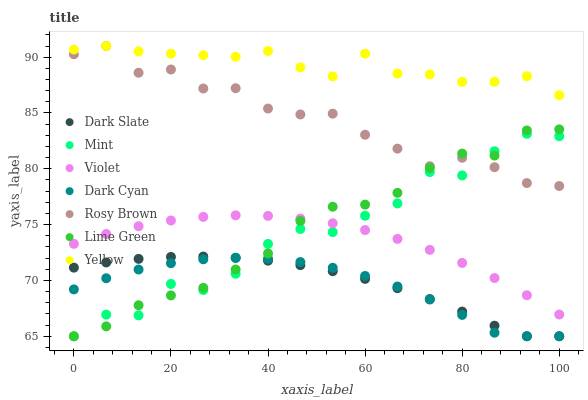Does Dark Cyan have the minimum area under the curve?
Answer yes or no. Yes. Does Yellow have the maximum area under the curve?
Answer yes or no. Yes. Does Rosy Brown have the minimum area under the curve?
Answer yes or no. No. Does Rosy Brown have the maximum area under the curve?
Answer yes or no. No. Is Violet the smoothest?
Answer yes or no. Yes. Is Mint the roughest?
Answer yes or no. Yes. Is Rosy Brown the smoothest?
Answer yes or no. No. Is Rosy Brown the roughest?
Answer yes or no. No. Does Lime Green have the lowest value?
Answer yes or no. Yes. Does Rosy Brown have the lowest value?
Answer yes or no. No. Does Yellow have the highest value?
Answer yes or no. Yes. Does Dark Slate have the highest value?
Answer yes or no. No. Is Dark Slate less than Violet?
Answer yes or no. Yes. Is Rosy Brown greater than Violet?
Answer yes or no. Yes. Does Mint intersect Dark Slate?
Answer yes or no. Yes. Is Mint less than Dark Slate?
Answer yes or no. No. Is Mint greater than Dark Slate?
Answer yes or no. No. Does Dark Slate intersect Violet?
Answer yes or no. No. 